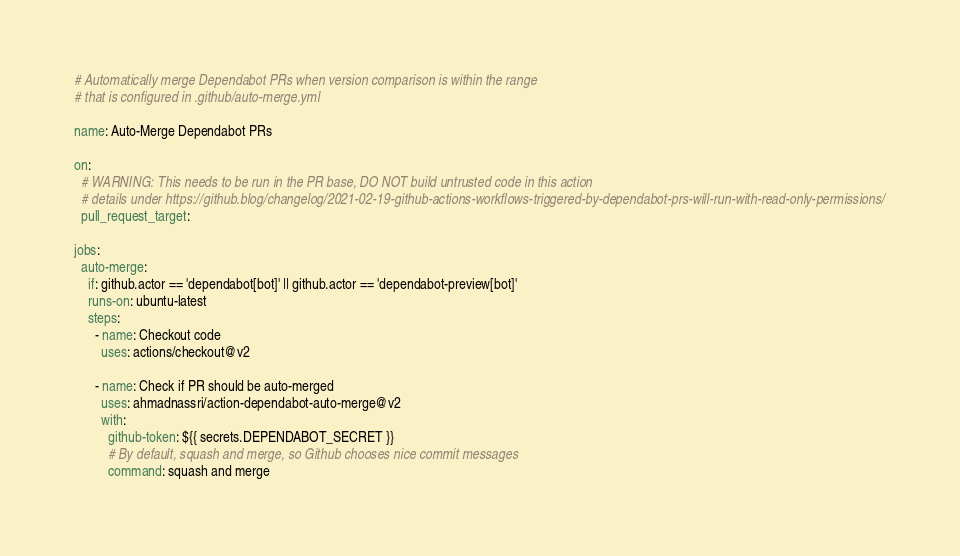Convert code to text. <code><loc_0><loc_0><loc_500><loc_500><_YAML_># Automatically merge Dependabot PRs when version comparison is within the range
# that is configured in .github/auto-merge.yml

name: Auto-Merge Dependabot PRs

on:
  # WARNING: This needs to be run in the PR base, DO NOT build untrusted code in this action
  # details under https://github.blog/changelog/2021-02-19-github-actions-workflows-triggered-by-dependabot-prs-will-run-with-read-only-permissions/
  pull_request_target:

jobs:
  auto-merge:
    if: github.actor == 'dependabot[bot]' || github.actor == 'dependabot-preview[bot]'
    runs-on: ubuntu-latest
    steps:
      - name: Checkout code
        uses: actions/checkout@v2

      - name: Check if PR should be auto-merged
        uses: ahmadnassri/action-dependabot-auto-merge@v2
        with:
          github-token: ${{ secrets.DEPENDABOT_SECRET }}
          # By default, squash and merge, so Github chooses nice commit messages
          command: squash and merge</code> 